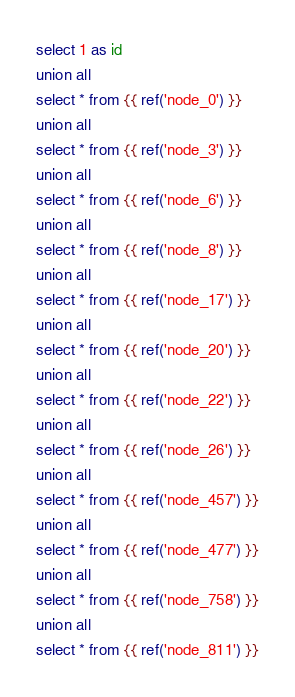Convert code to text. <code><loc_0><loc_0><loc_500><loc_500><_SQL_>select 1 as id
union all
select * from {{ ref('node_0') }}
union all
select * from {{ ref('node_3') }}
union all
select * from {{ ref('node_6') }}
union all
select * from {{ ref('node_8') }}
union all
select * from {{ ref('node_17') }}
union all
select * from {{ ref('node_20') }}
union all
select * from {{ ref('node_22') }}
union all
select * from {{ ref('node_26') }}
union all
select * from {{ ref('node_457') }}
union all
select * from {{ ref('node_477') }}
union all
select * from {{ ref('node_758') }}
union all
select * from {{ ref('node_811') }}</code> 